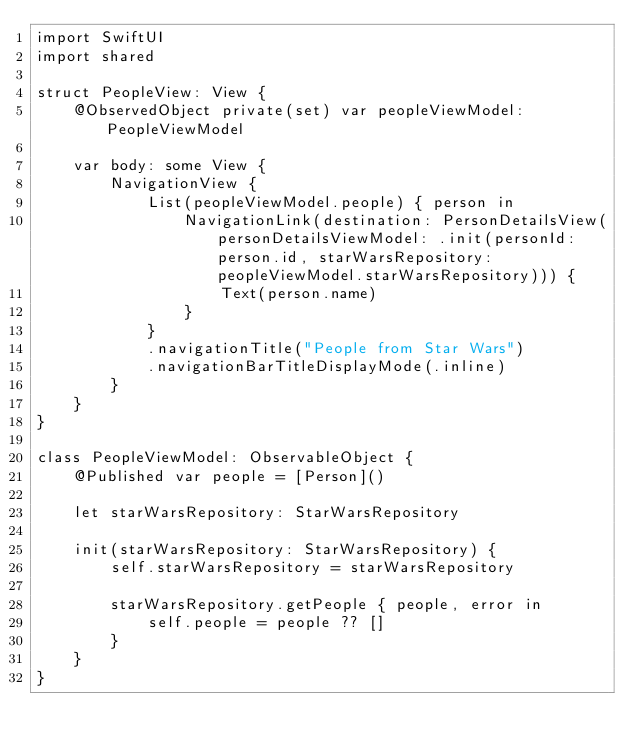<code> <loc_0><loc_0><loc_500><loc_500><_Swift_>import SwiftUI
import shared

struct PeopleView: View {
    @ObservedObject private(set) var peopleViewModel: PeopleViewModel
    
    var body: some View {
        NavigationView {
            List(peopleViewModel.people) { person in
                NavigationLink(destination: PersonDetailsView(personDetailsViewModel: .init(personId: person.id, starWarsRepository: peopleViewModel.starWarsRepository))) {
                    Text(person.name)
                }
            }
            .navigationTitle("People from Star Wars")
            .navigationBarTitleDisplayMode(.inline)
        }
    }
}

class PeopleViewModel: ObservableObject {
    @Published var people = [Person]()
    
    let starWarsRepository: StarWarsRepository
    
    init(starWarsRepository: StarWarsRepository) {
        self.starWarsRepository = starWarsRepository
        
        starWarsRepository.getPeople { people, error in
            self.people = people ?? []
        }
    }
}
</code> 